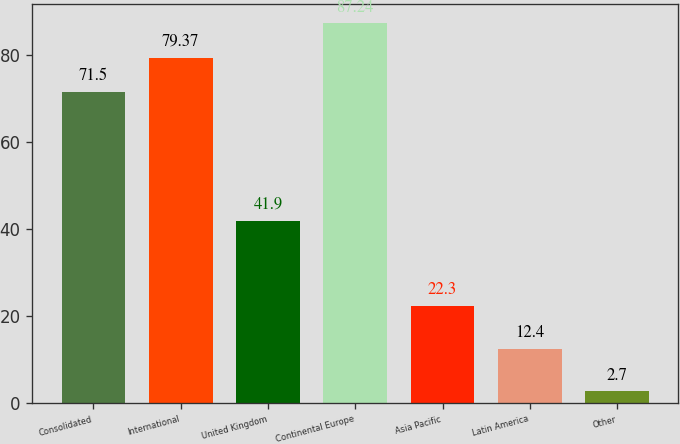Convert chart. <chart><loc_0><loc_0><loc_500><loc_500><bar_chart><fcel>Consolidated<fcel>International<fcel>United Kingdom<fcel>Continental Europe<fcel>Asia Pacific<fcel>Latin America<fcel>Other<nl><fcel>71.5<fcel>79.37<fcel>41.9<fcel>87.24<fcel>22.3<fcel>12.4<fcel>2.7<nl></chart> 